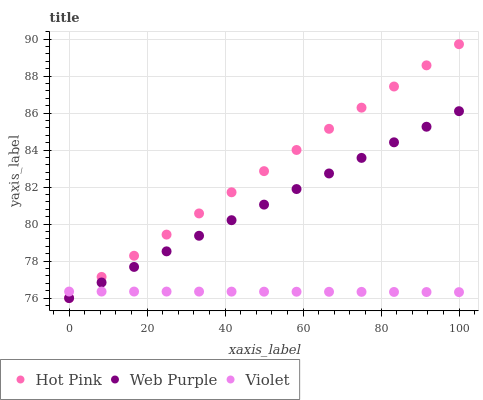Does Violet have the minimum area under the curve?
Answer yes or no. Yes. Does Hot Pink have the maximum area under the curve?
Answer yes or no. Yes. Does Hot Pink have the minimum area under the curve?
Answer yes or no. No. Does Violet have the maximum area under the curve?
Answer yes or no. No. Is Hot Pink the smoothest?
Answer yes or no. Yes. Is Violet the roughest?
Answer yes or no. Yes. Is Violet the smoothest?
Answer yes or no. No. Is Hot Pink the roughest?
Answer yes or no. No. Does Web Purple have the lowest value?
Answer yes or no. Yes. Does Violet have the lowest value?
Answer yes or no. No. Does Hot Pink have the highest value?
Answer yes or no. Yes. Does Violet have the highest value?
Answer yes or no. No. Does Violet intersect Hot Pink?
Answer yes or no. Yes. Is Violet less than Hot Pink?
Answer yes or no. No. Is Violet greater than Hot Pink?
Answer yes or no. No. 